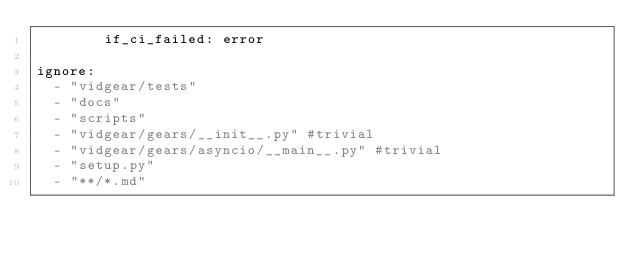<code> <loc_0><loc_0><loc_500><loc_500><_YAML_>        if_ci_failed: error
        
ignore:
  - "vidgear/tests"
  - "docs"
  - "scripts"
  - "vidgear/gears/__init__.py" #trivial
  - "vidgear/gears/asyncio/__main__.py" #trivial
  - "setup.py"
  - "**/*.md"</code> 